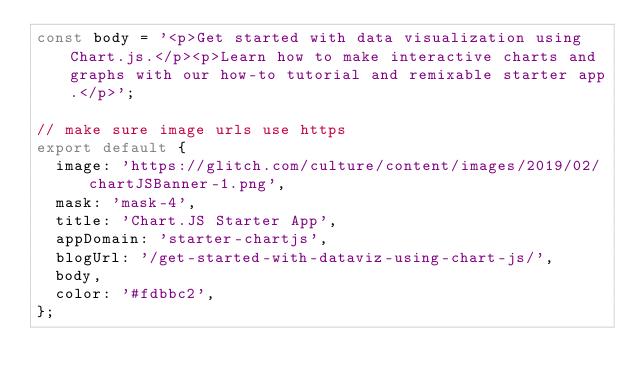Convert code to text. <code><loc_0><loc_0><loc_500><loc_500><_JavaScript_>const body = '<p>Get started with data visualization using Chart.js.</p><p>Learn how to make interactive charts and graphs with our how-to tutorial and remixable starter app.</p>';

// make sure image urls use https
export default {
  image: 'https://glitch.com/culture/content/images/2019/02/chartJSBanner-1.png',
  mask: 'mask-4',
  title: 'Chart.JS Starter App',
  appDomain: 'starter-chartjs',
  blogUrl: '/get-started-with-dataviz-using-chart-js/',
  body,
  color: '#fdbbc2',
};
</code> 